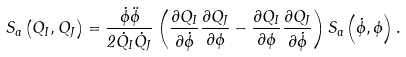<formula> <loc_0><loc_0><loc_500><loc_500>S _ { a } \left ( Q _ { I } , Q _ { J } \right ) = \frac { \dot { \phi } \ddot { \phi } } { 2 \dot { Q } _ { I } \dot { Q } _ { J } } \left ( \frac { \partial Q _ { I } } { \partial \dot { \phi } } \frac { \partial Q _ { J } } { \partial \phi } - \frac { \partial Q _ { I } } { \partial \phi } \frac { \partial Q _ { J } } { \partial \dot { \phi } } \right ) S _ { a } \left ( \dot { \phi } , \phi \right ) .</formula> 